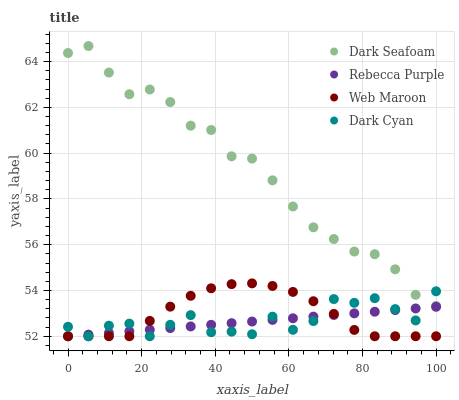Does Rebecca Purple have the minimum area under the curve?
Answer yes or no. Yes. Does Dark Seafoam have the maximum area under the curve?
Answer yes or no. Yes. Does Web Maroon have the minimum area under the curve?
Answer yes or no. No. Does Web Maroon have the maximum area under the curve?
Answer yes or no. No. Is Rebecca Purple the smoothest?
Answer yes or no. Yes. Is Dark Cyan the roughest?
Answer yes or no. Yes. Is Dark Seafoam the smoothest?
Answer yes or no. No. Is Dark Seafoam the roughest?
Answer yes or no. No. Does Dark Cyan have the lowest value?
Answer yes or no. Yes. Does Dark Seafoam have the lowest value?
Answer yes or no. No. Does Dark Seafoam have the highest value?
Answer yes or no. Yes. Does Web Maroon have the highest value?
Answer yes or no. No. Is Web Maroon less than Dark Seafoam?
Answer yes or no. Yes. Is Dark Seafoam greater than Rebecca Purple?
Answer yes or no. Yes. Does Dark Cyan intersect Dark Seafoam?
Answer yes or no. Yes. Is Dark Cyan less than Dark Seafoam?
Answer yes or no. No. Is Dark Cyan greater than Dark Seafoam?
Answer yes or no. No. Does Web Maroon intersect Dark Seafoam?
Answer yes or no. No. 